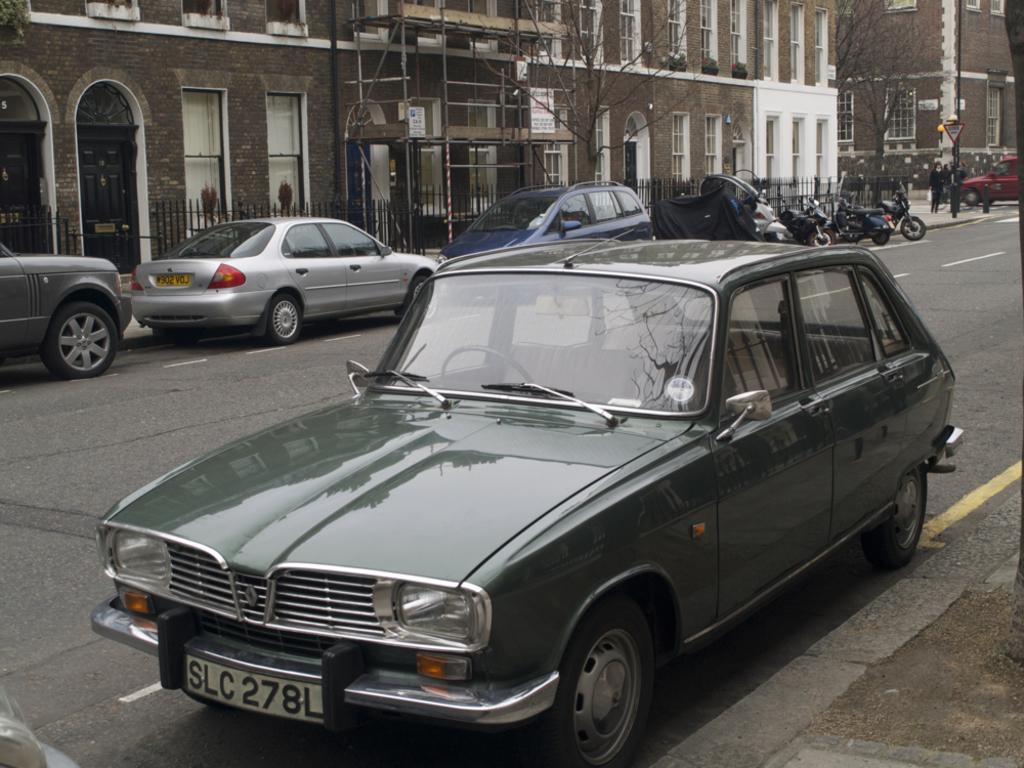Could you give a brief overview of what you see in this image? In this image, we can see vehicles on the road and there are some people. In the background, there are buildings, trees and we can see poles and railings. 